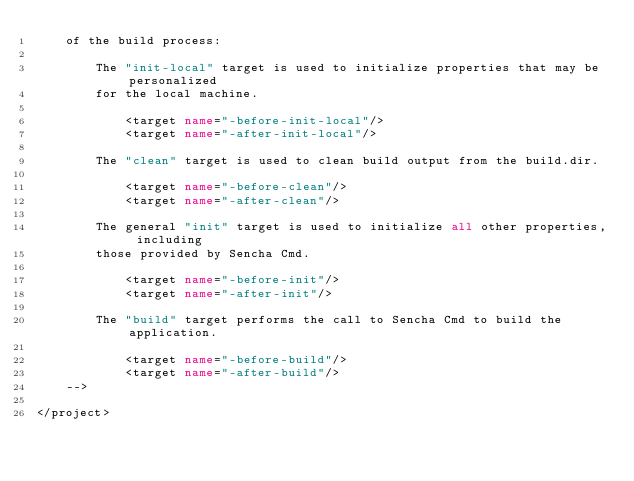<code> <loc_0><loc_0><loc_500><loc_500><_XML_>    of the build process:

        The "init-local" target is used to initialize properties that may be personalized
        for the local machine.

            <target name="-before-init-local"/>
            <target name="-after-init-local"/>

        The "clean" target is used to clean build output from the build.dir.

            <target name="-before-clean"/>
            <target name="-after-clean"/>

        The general "init" target is used to initialize all other properties, including
        those provided by Sencha Cmd.

            <target name="-before-init"/>
            <target name="-after-init"/>

        The "build" target performs the call to Sencha Cmd to build the application.

            <target name="-before-build"/>
            <target name="-after-build"/>
    -->

</project>
</code> 